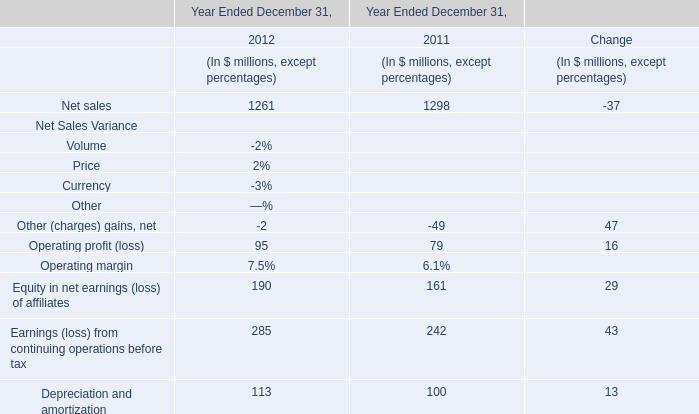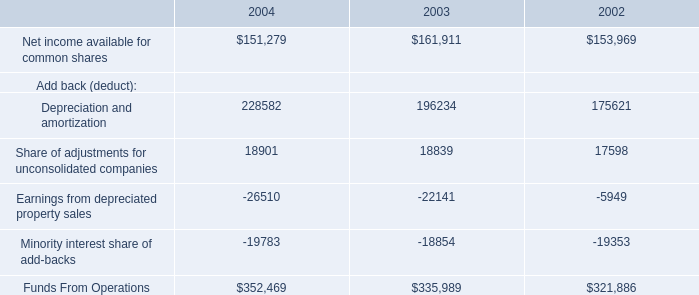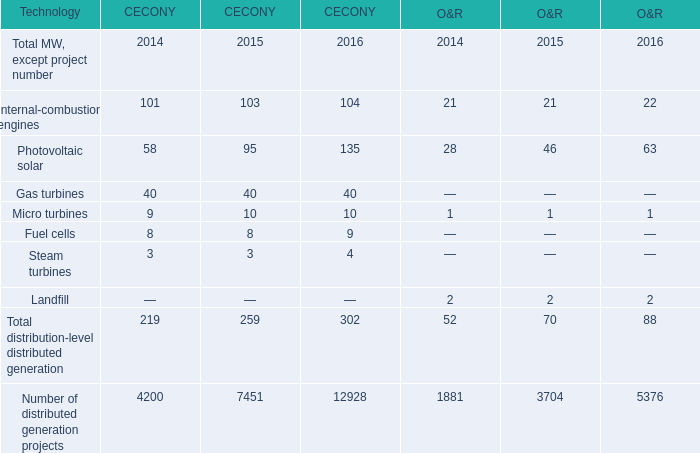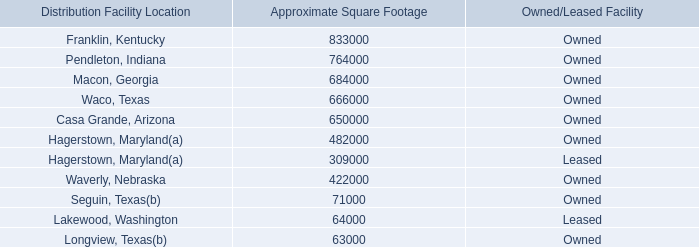What's the total amount of theGas turbines in the years where Micro turbines greater than 10? 
Computations: (40 + 40)
Answer: 80.0. 